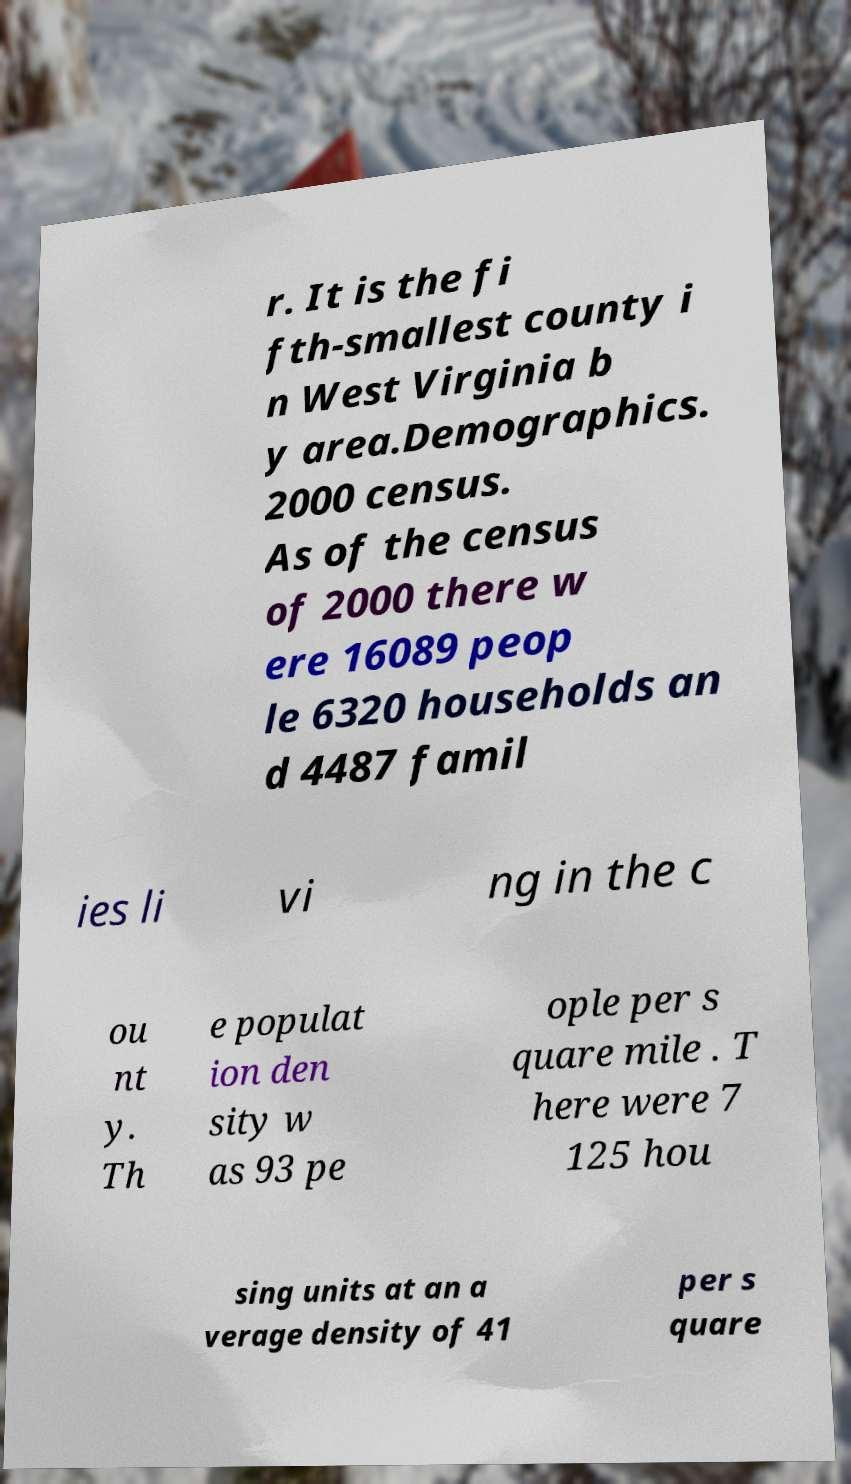For documentation purposes, I need the text within this image transcribed. Could you provide that? r. It is the fi fth-smallest county i n West Virginia b y area.Demographics. 2000 census. As of the census of 2000 there w ere 16089 peop le 6320 households an d 4487 famil ies li vi ng in the c ou nt y. Th e populat ion den sity w as 93 pe ople per s quare mile . T here were 7 125 hou sing units at an a verage density of 41 per s quare 